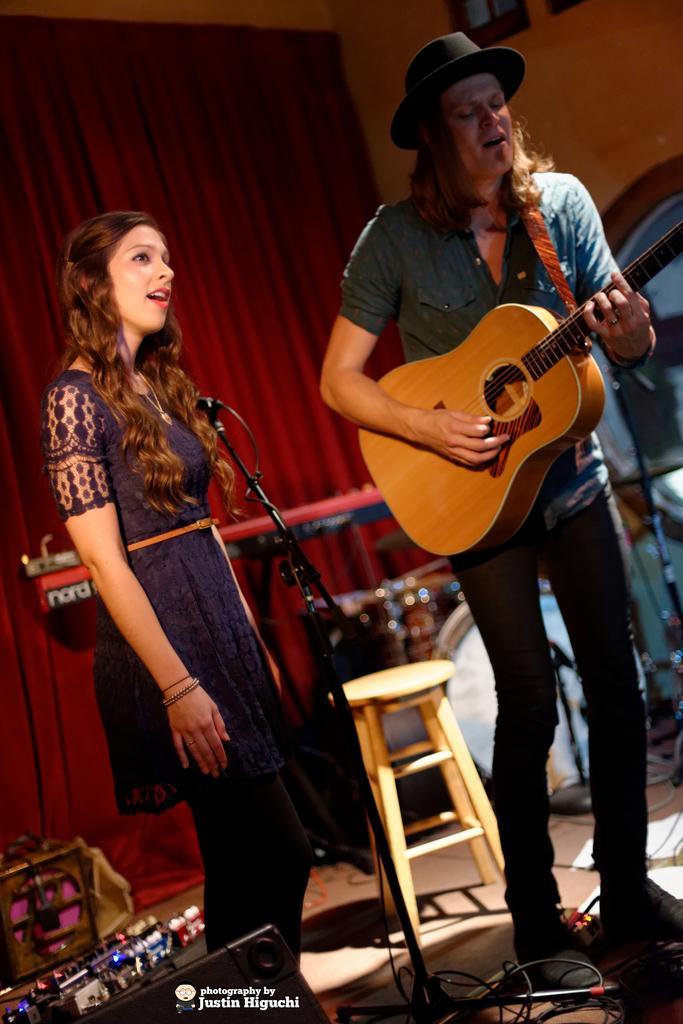Describe this image in one or two sentences. In this image, on the right side there is a man who is standing and holding a music instrument, In the middle there is a table of yellow color, on the left side there is a woman standing and she i singing in microphone and in the background there is a wall covered by a red curtain. 